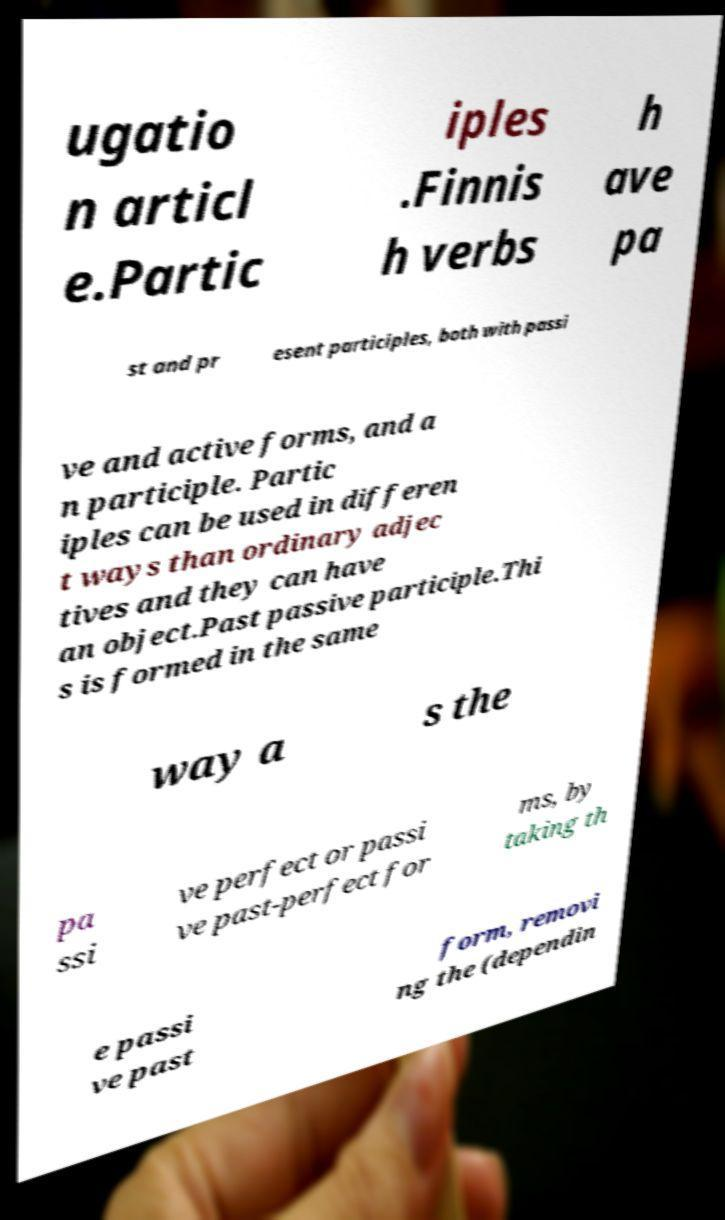There's text embedded in this image that I need extracted. Can you transcribe it verbatim? ugatio n articl e.Partic iples .Finnis h verbs h ave pa st and pr esent participles, both with passi ve and active forms, and a n participle. Partic iples can be used in differen t ways than ordinary adjec tives and they can have an object.Past passive participle.Thi s is formed in the same way a s the pa ssi ve perfect or passi ve past-perfect for ms, by taking th e passi ve past form, removi ng the (dependin 